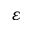Convert formula to latex. <formula><loc_0><loc_0><loc_500><loc_500>\varepsilon</formula> 